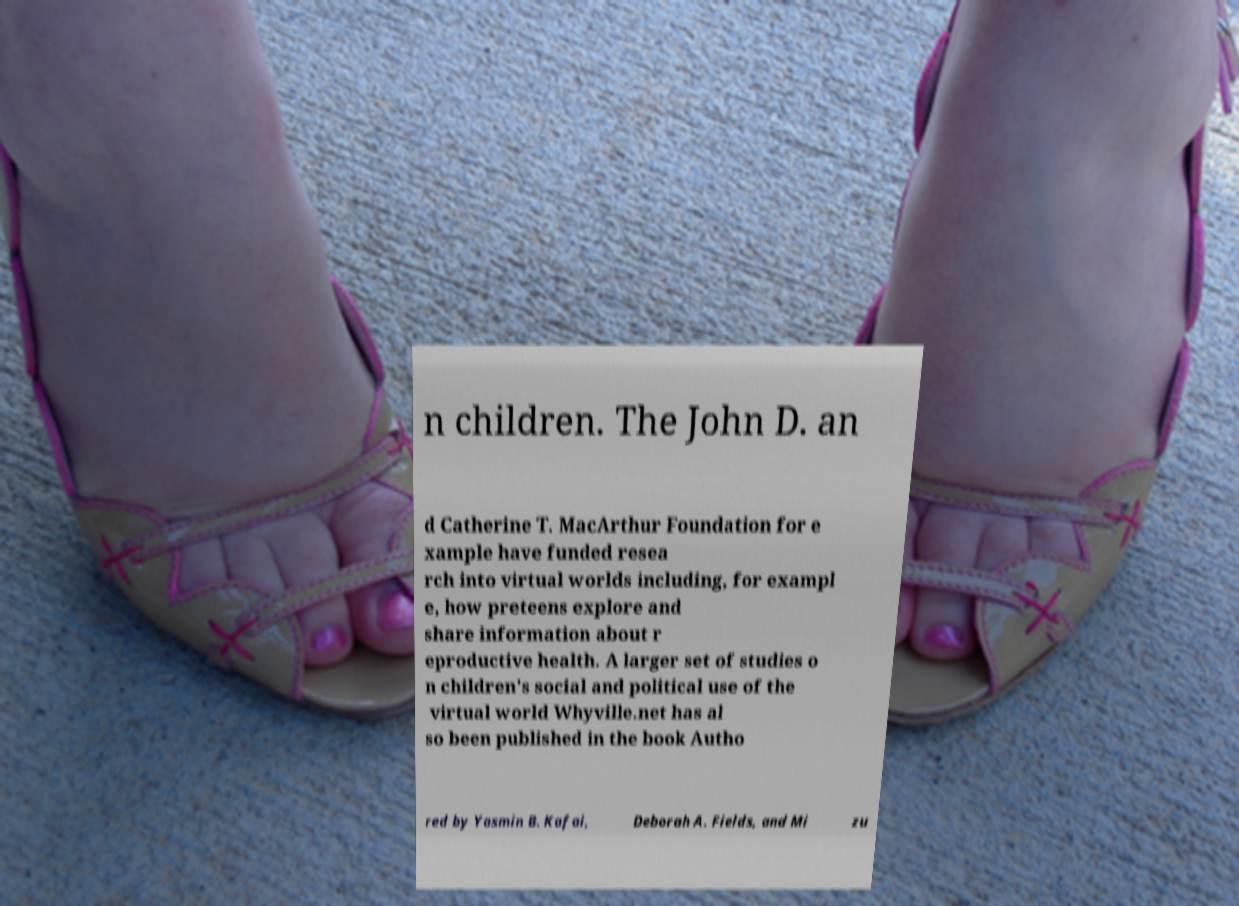Please identify and transcribe the text found in this image. n children. The John D. an d Catherine T. MacArthur Foundation for e xample have funded resea rch into virtual worlds including, for exampl e, how preteens explore and share information about r eproductive health. A larger set of studies o n children's social and political use of the virtual world Whyville.net has al so been published in the book Autho red by Yasmin B. Kafai, Deborah A. Fields, and Mi zu 